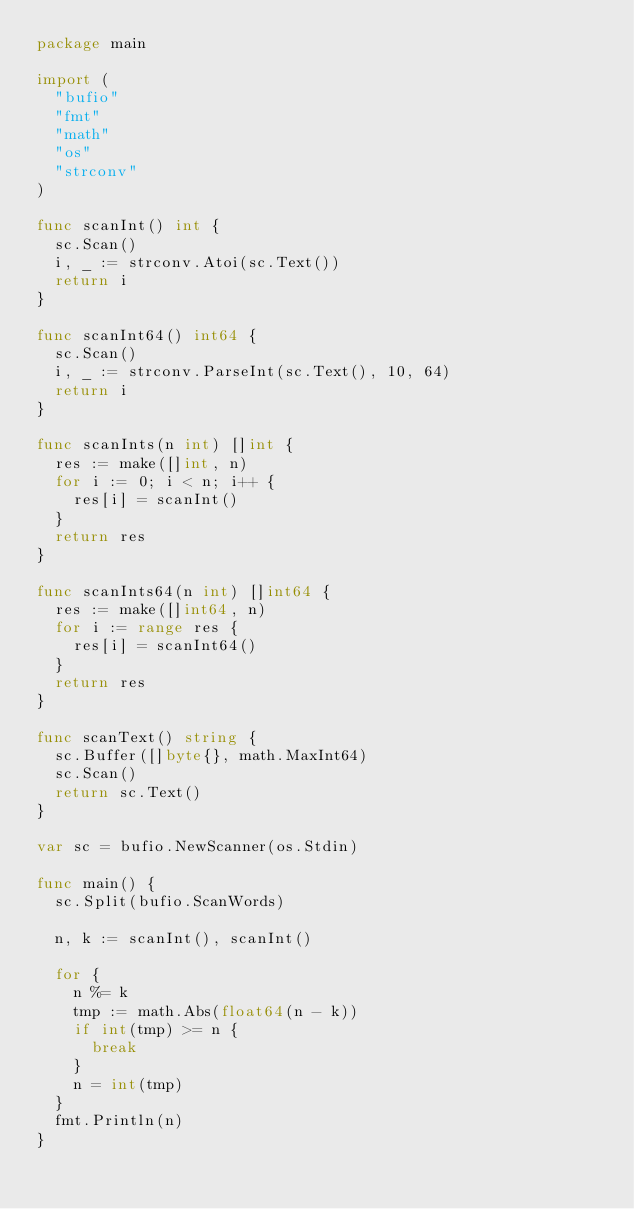<code> <loc_0><loc_0><loc_500><loc_500><_Go_>package main

import (
	"bufio"
	"fmt"
	"math"
	"os"
	"strconv"
)

func scanInt() int {
	sc.Scan()
	i, _ := strconv.Atoi(sc.Text())
	return i
}

func scanInt64() int64 {
	sc.Scan()
	i, _ := strconv.ParseInt(sc.Text(), 10, 64)
	return i
}

func scanInts(n int) []int {
	res := make([]int, n)
	for i := 0; i < n; i++ {
		res[i] = scanInt()
	}
	return res
}

func scanInts64(n int) []int64 {
	res := make([]int64, n)
	for i := range res {
		res[i] = scanInt64()
	}
	return res
}

func scanText() string {
	sc.Buffer([]byte{}, math.MaxInt64)
	sc.Scan()
	return sc.Text()
}

var sc = bufio.NewScanner(os.Stdin)

func main() {
	sc.Split(bufio.ScanWords)

	n, k := scanInt(), scanInt()

	for {
		n %= k
		tmp := math.Abs(float64(n - k))
		if int(tmp) >= n {
			break
		}
		n = int(tmp)
	}
	fmt.Println(n)
}
</code> 